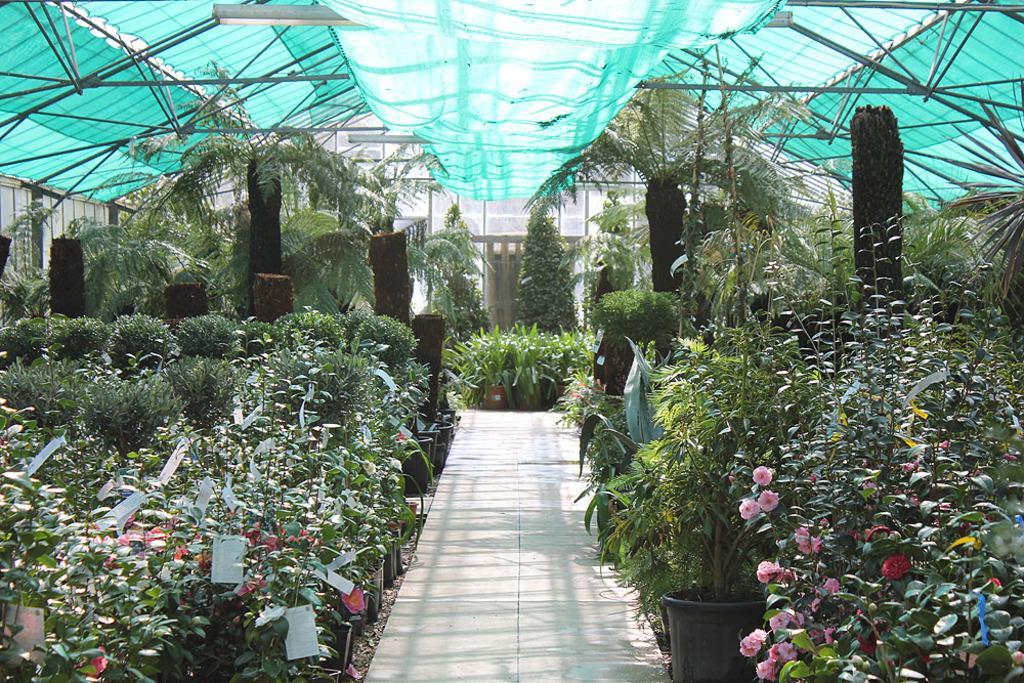Please provide a concise description of this image. I think this picture is taken in a plant nursery. In the center, there is a lane. In both the sides of the picture, there are plants with different flowers. On the top, there is a shed and cloth. 